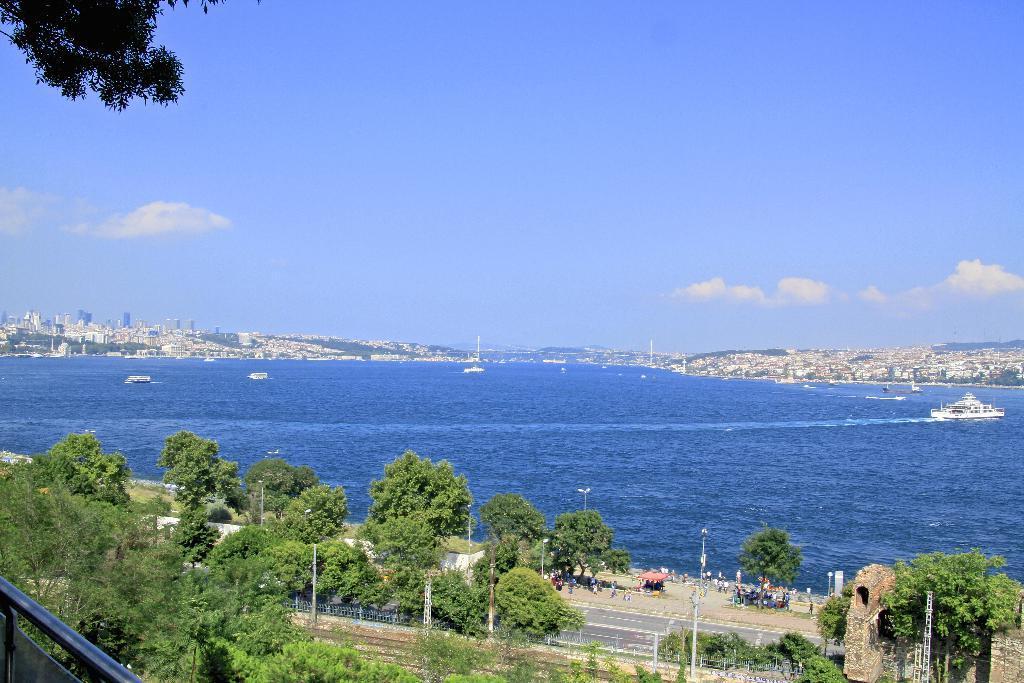Describe this image in one or two sentences. Completely an outdoor picture. The river is in blue color and it as freshwater. Far there are many buildings. The boat is floating on river. Far there are number of trees. Road. 